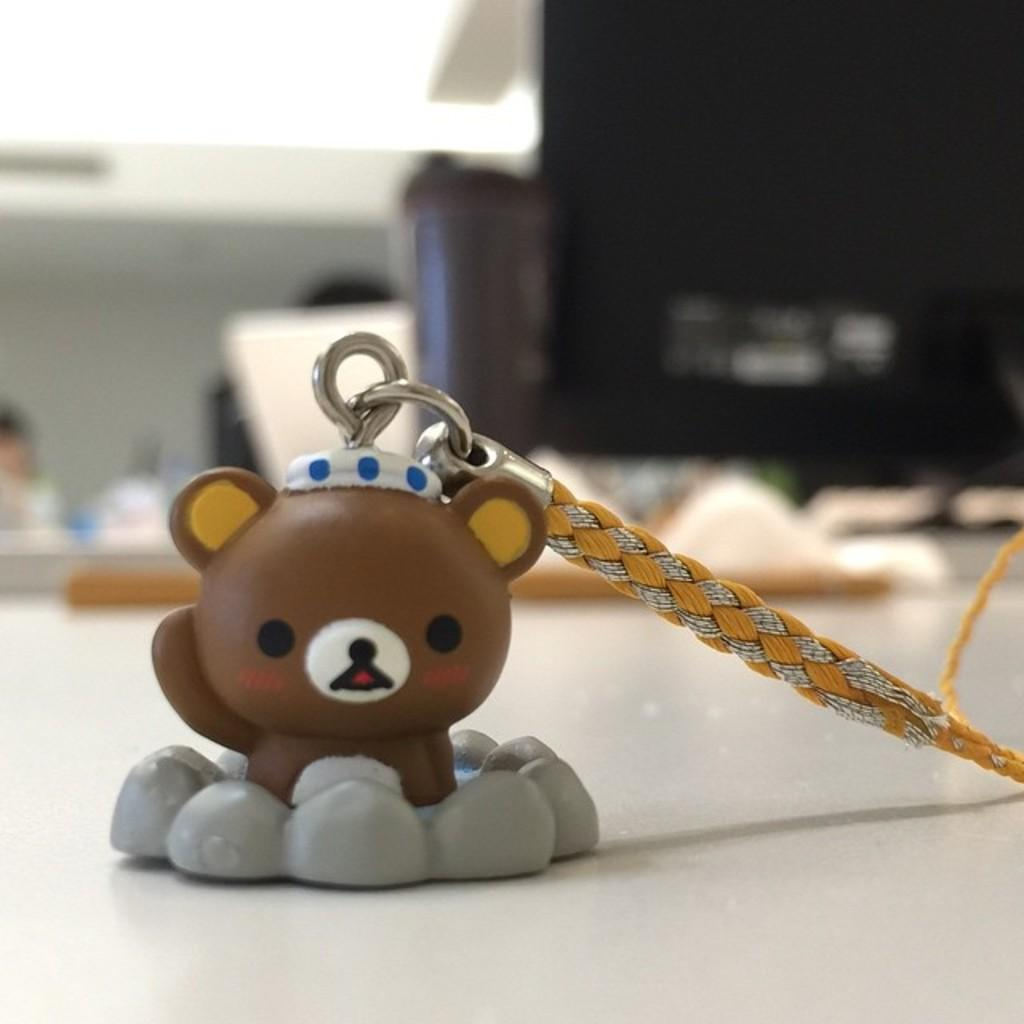What type of toy is in the image? There is a toy locket in the image. What is the toy locket placed on? The toy locket is on a white desk surface. What is attached to the toy locket? There is a belt on the toy locket. What electronic device is visible in the image? There is a monitor in the image. What is the color of the monitor? The monitor is black in color. What can be seen behind the monitor? There are desks behind the monitor. What are the persons at the desks doing? There are persons sitting at the desks. What type of sidewalk can be seen in the image? There is no sidewalk present in the image; it features a toy locket, a white desk surface, a belt, a monitor, desks, and persons sitting at the desks. 